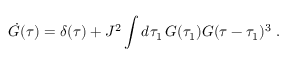Convert formula to latex. <formula><loc_0><loc_0><loc_500><loc_500>\dot { G } ( \tau ) = \delta ( \tau ) + J ^ { 2 } \int d \tau _ { 1 } \, G ( \tau _ { 1 } ) G ( \tau - \tau _ { 1 } ) ^ { 3 } .</formula> 